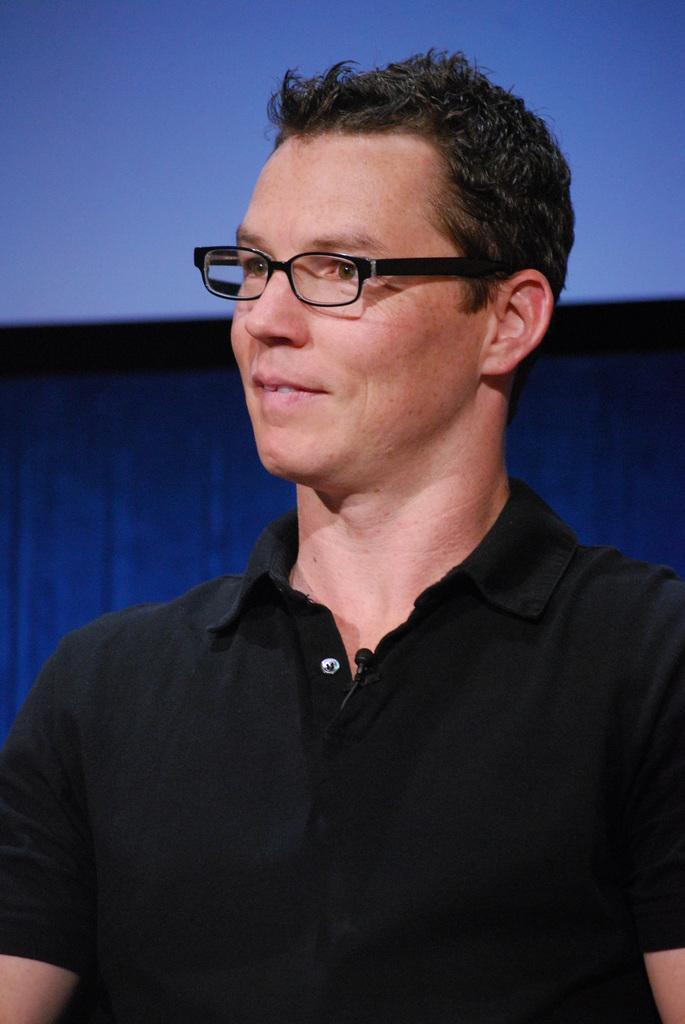Please provide a concise description of this image. In this image I can see a person wearing black colored dress and spectacles. I can see the blue and black colored background. 